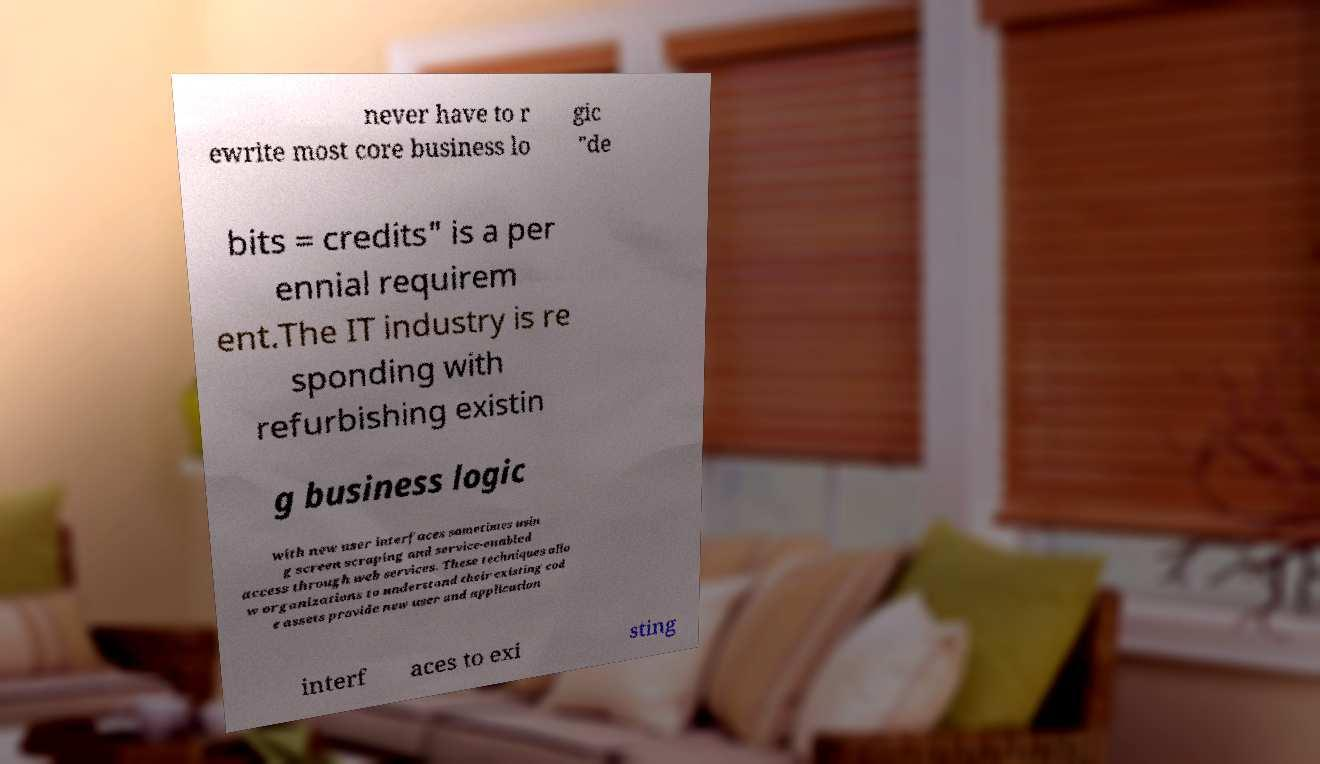Could you assist in decoding the text presented in this image and type it out clearly? never have to r ewrite most core business lo gic "de bits = credits" is a per ennial requirem ent.The IT industry is re sponding with refurbishing existin g business logic with new user interfaces sometimes usin g screen scraping and service-enabled access through web services. These techniques allo w organizations to understand their existing cod e assets provide new user and application interf aces to exi sting 